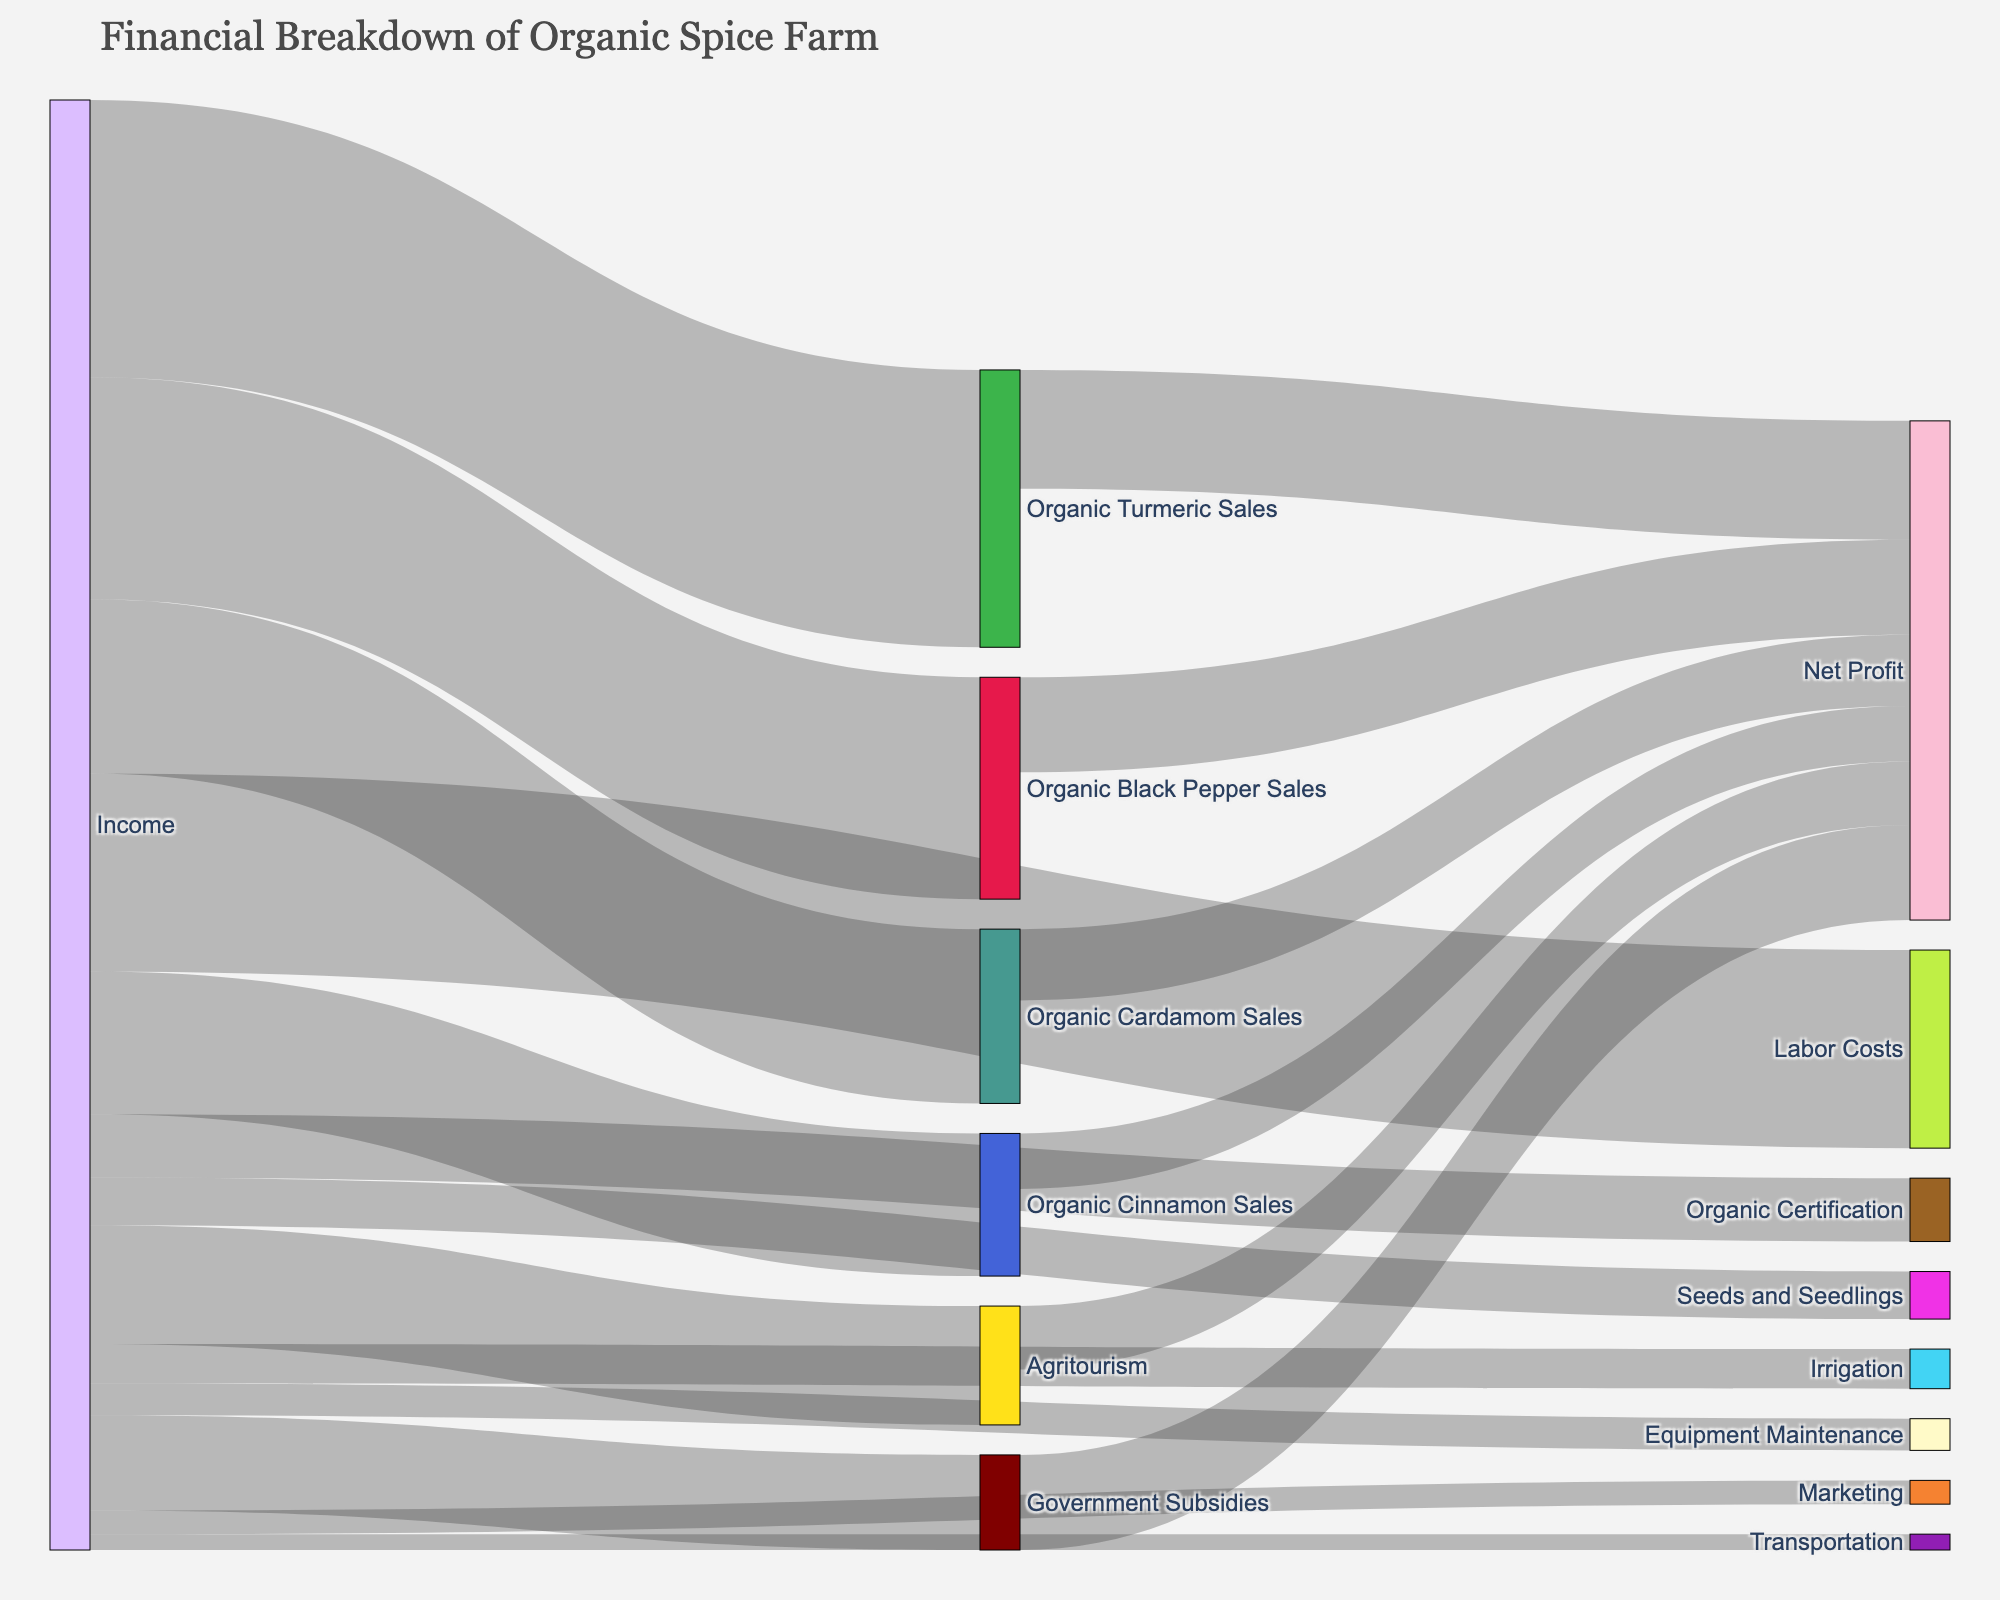What is the total income from spice sales? The income from spice sales can be found by summing the values associated with Organic Turmeric Sales (35,000), Organic Black Pepper Sales (28,000), Organic Cardamom Sales (22,000), and Organic Cinnamon Sales (18,000). So, 35,000 + 28,000 + 22,000 + 18,000 equals 103,000.
Answer: 103,000 Which income source contributes the most to the farm’s income? By examining the nodes connected to "Income," we can see that Organic Turmeric Sales, at 35,000, contributes the most to the farm's income.
Answer: Organic Turmeric Sales What is the total value associated with labor costs? The value associated with Labor Costs is explicitly listed as 25,000.
Answer: 25,000 Which has a higher net profit: Organic Black Pepper Sales or Agritourism? Comparing the net profits, Organic Black Pepper Sales has a net profit of 12,000, whereas Agritourism has a net profit of 8,000. Therefore, Organic Black Pepper Sales has a higher net profit.
Answer: Organic Black Pepper Sales How much does the farm spend on Seeds and Seedlings in comparison to Marketing? The farm spends 6,000 on Seeds and Seedlings and 3,000 on Marketing. Comparing these, the farm spends twice as much on Seeds and Seedlings as it does on Marketing.
Answer: Twice as much on Seeds and Seedlings What is the cumulative net profit from all income sources? The net profits from all income sources can be summed as follows: Organic Turmeric Sales (15,000) + Organic Black Pepper Sales (12,000) + Organic Cardamom Sales (9,000) + Organic Cinnamon Sales (7,000) + Agritourism (8,000) + Government Subsidies (12,000) results in a total of 63,000.
Answer: 63,000 What percentage of the total income is contributed by Agritourism? Total income is calculated as 166,000 from the sum of all income sources. Agritourism contributes 15,000 to this total. The percentage is calculated as (15,000 / 166,000) * 100, which is approximately 9.04%.
Answer: 9.04% Which expense category has the lowest value and what is it? Among the expense categories, Transportation has the lowest value, which is 2,000.
Answer: Transportation How do the total expenses compare with the net profit? Total expenses are calculated as the sum of the values for Labor Costs (25,000), Organic Certification (8,000), Seeds and Seedlings (6,000), Irrigation (5,000), Equipment Maintenance (4,000), Marketing (3,000), and Transportation (2,000), resulting in 53,000. The net profit is 63,000. Net profit is higher than total expenses by 10,000.
Answer: Net profit is 10,000 higher What is the difference between the highest and lowest income sources? The highest income source is Organic Turmeric Sales at 35,000. The lowest income source is Government Subsidies at 12,000. The difference between them is 35,000 - 12,000, which is 23,000.
Answer: 23,000 